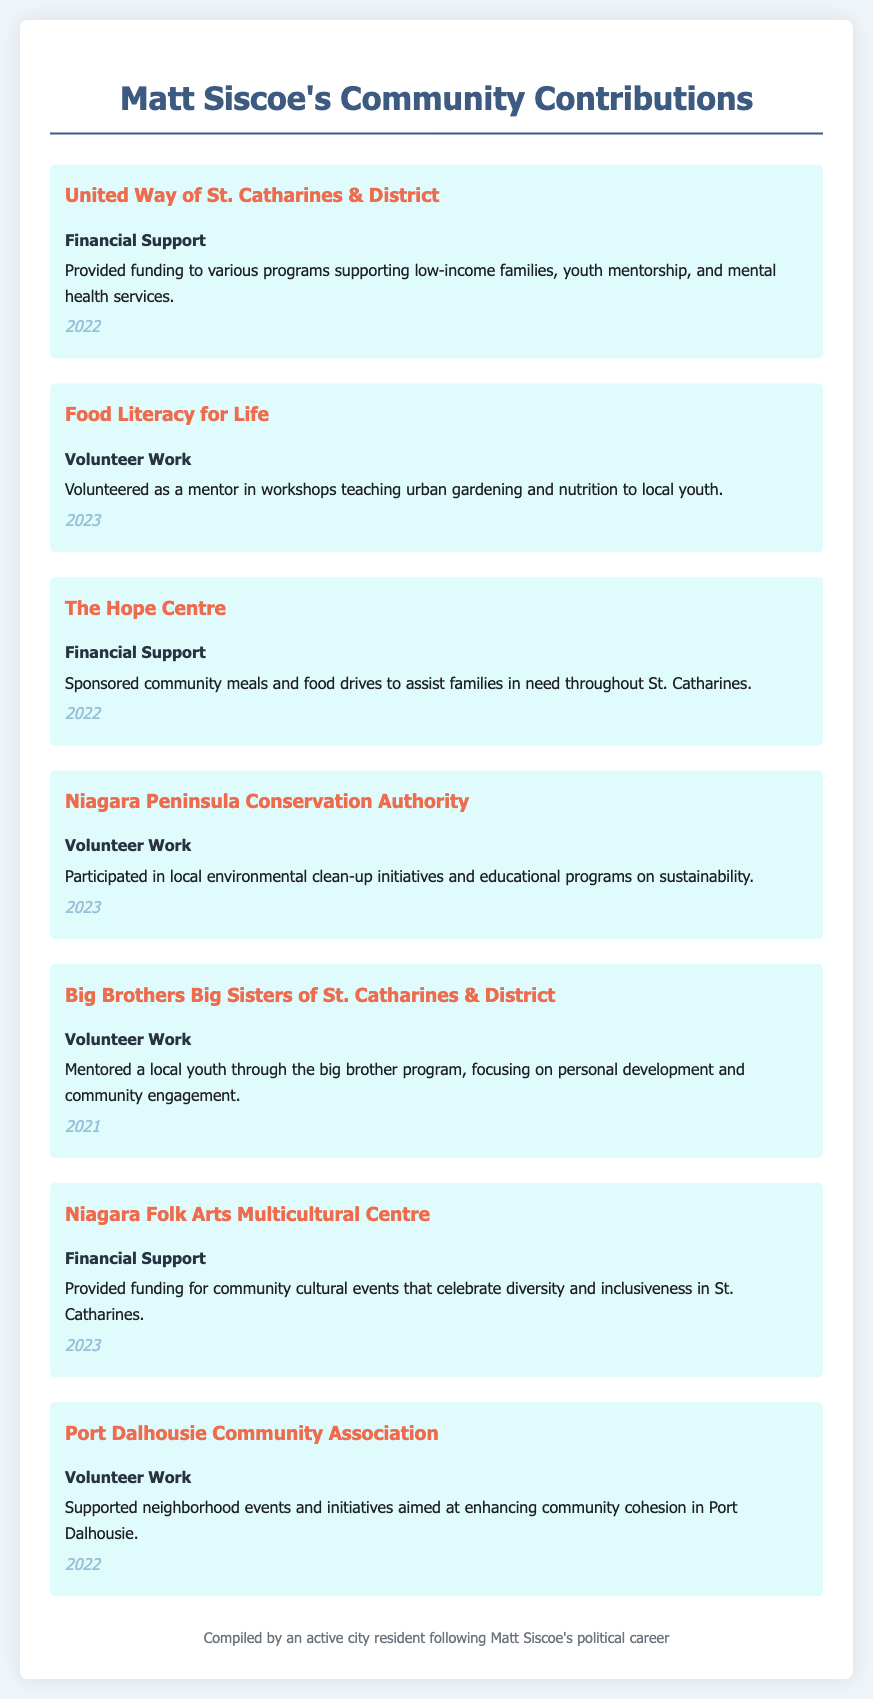what year did Matt Siscoe provide financial support to the United Way of St. Catharines & District? The document states that Matt Siscoe provided financial support to the United Way in the year 2022.
Answer: 2022 what type of contribution did Matt Siscoe make to the Food Literacy for Life initiative? The document indicates that Siscoe's contribution to Food Literacy for Life was through volunteer work.
Answer: Volunteer Work how many initiatives supported by Siscoe involved financial support? The document lists three initiatives where Siscoe provided financial support.
Answer: Three which organization did Matt Siscoe volunteer with to participate in environmental clean-up initiatives? The document specifies that he volunteered with the Niagara Peninsula Conservation Authority for environmental clean-up initiatives.
Answer: Niagara Peninsula Conservation Authority what was the focus of Matt Siscoe's mentorship with Big Brothers Big Sisters of St. Catharines & District? The document mentions that Siscoe's mentorship focused on personal development and community engagement.
Answer: Personal development and community engagement what type of events did Siscoe provide funding for at the Niagara Folk Arts Multicultural Centre? The document notes that he provided funding for community cultural events celebrating diversity and inclusiveness.
Answer: Community cultural events 